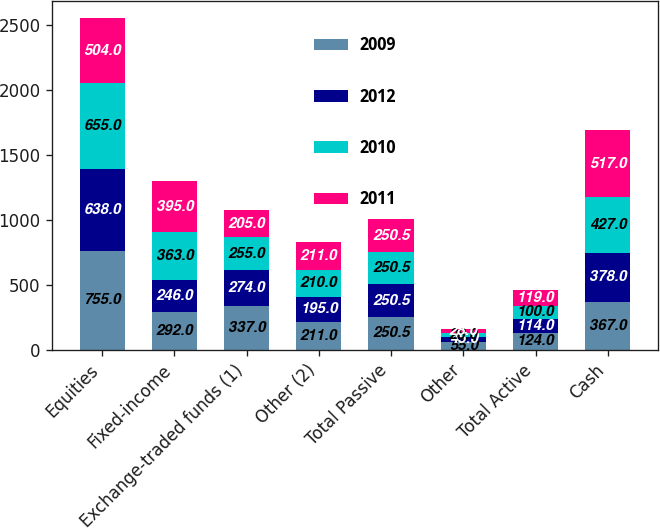<chart> <loc_0><loc_0><loc_500><loc_500><stacked_bar_chart><ecel><fcel>Equities<fcel>Fixed-income<fcel>Exchange-traded funds (1)<fcel>Other (2)<fcel>Total Passive<fcel>Other<fcel>Total Active<fcel>Cash<nl><fcel>2009<fcel>755<fcel>292<fcel>337<fcel>211<fcel>250.5<fcel>55<fcel>124<fcel>367<nl><fcel>2012<fcel>638<fcel>246<fcel>274<fcel>195<fcel>250.5<fcel>45<fcel>114<fcel>378<nl><fcel>2010<fcel>655<fcel>363<fcel>255<fcel>210<fcel>250.5<fcel>28<fcel>100<fcel>427<nl><fcel>2011<fcel>504<fcel>395<fcel>205<fcel>211<fcel>250.5<fcel>28<fcel>119<fcel>517<nl></chart> 